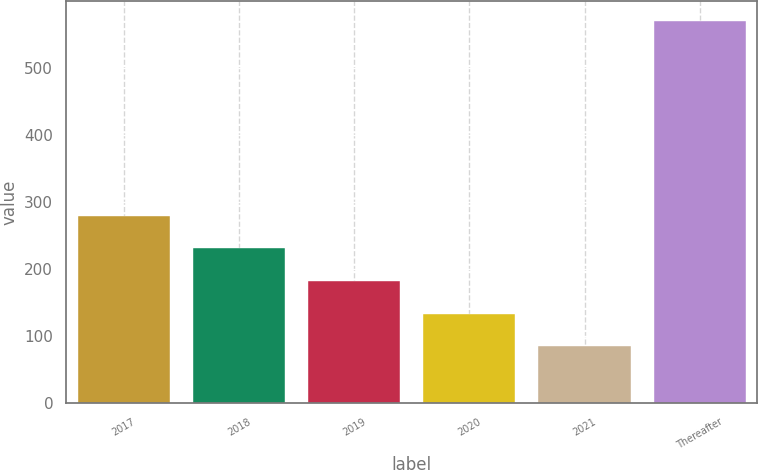Convert chart. <chart><loc_0><loc_0><loc_500><loc_500><bar_chart><fcel>2017<fcel>2018<fcel>2019<fcel>2020<fcel>2021<fcel>Thereafter<nl><fcel>279.4<fcel>230.8<fcel>182.2<fcel>133.6<fcel>85<fcel>571<nl></chart> 